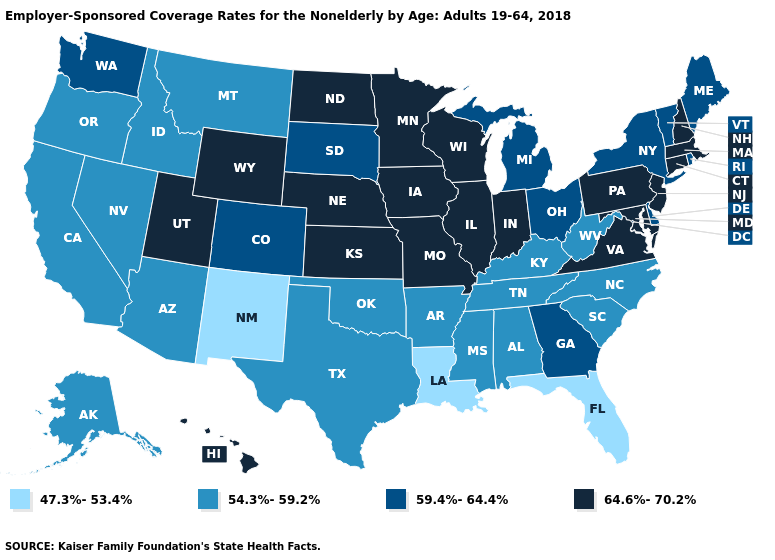Name the states that have a value in the range 47.3%-53.4%?
Write a very short answer. Florida, Louisiana, New Mexico. What is the value of Arizona?
Be succinct. 54.3%-59.2%. Does the map have missing data?
Concise answer only. No. What is the lowest value in the MidWest?
Quick response, please. 59.4%-64.4%. Does the first symbol in the legend represent the smallest category?
Give a very brief answer. Yes. Among the states that border Arkansas , which have the lowest value?
Give a very brief answer. Louisiana. Name the states that have a value in the range 47.3%-53.4%?
Be succinct. Florida, Louisiana, New Mexico. Does Pennsylvania have a higher value than Alabama?
Concise answer only. Yes. Name the states that have a value in the range 54.3%-59.2%?
Give a very brief answer. Alabama, Alaska, Arizona, Arkansas, California, Idaho, Kentucky, Mississippi, Montana, Nevada, North Carolina, Oklahoma, Oregon, South Carolina, Tennessee, Texas, West Virginia. Among the states that border Maryland , does West Virginia have the lowest value?
Concise answer only. Yes. Does the first symbol in the legend represent the smallest category?
Keep it brief. Yes. Does South Carolina have the highest value in the USA?
Quick response, please. No. Does Missouri have the lowest value in the MidWest?
Short answer required. No. Does the map have missing data?
Keep it brief. No. Does Colorado have the highest value in the West?
Quick response, please. No. 